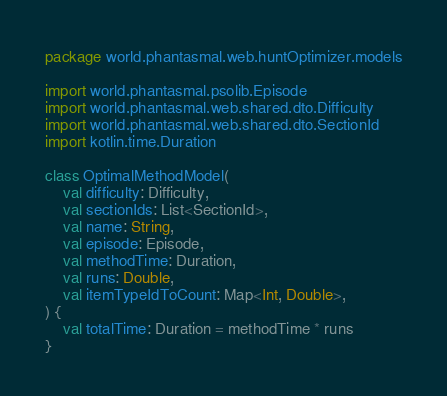Convert code to text. <code><loc_0><loc_0><loc_500><loc_500><_Kotlin_>package world.phantasmal.web.huntOptimizer.models

import world.phantasmal.psolib.Episode
import world.phantasmal.web.shared.dto.Difficulty
import world.phantasmal.web.shared.dto.SectionId
import kotlin.time.Duration

class OptimalMethodModel(
    val difficulty: Difficulty,
    val sectionIds: List<SectionId>,
    val name: String,
    val episode: Episode,
    val methodTime: Duration,
    val runs: Double,
    val itemTypeIdToCount: Map<Int, Double>,
) {
    val totalTime: Duration = methodTime * runs
}
</code> 